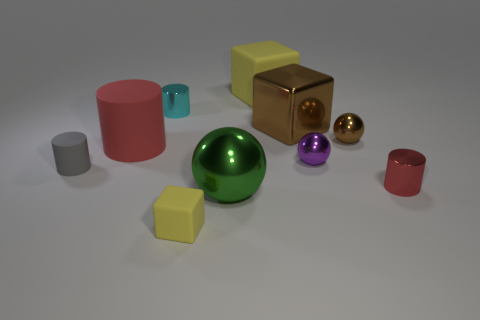What is the material of the yellow object that is in front of the small metal cylinder in front of the large brown cube?
Offer a very short reply. Rubber. Is there a brown metallic object that has the same shape as the gray thing?
Your answer should be very brief. No. What is the shape of the gray thing?
Give a very brief answer. Cylinder. There is a yellow object behind the metal cylinder in front of the brown shiny thing on the right side of the large brown thing; what is its material?
Make the answer very short. Rubber. Are there more yellow matte things to the left of the large red matte object than big green things?
Ensure brevity in your answer.  No. There is a cube that is the same size as the gray cylinder; what is its material?
Ensure brevity in your answer.  Rubber. Is there a matte cube of the same size as the cyan shiny object?
Offer a terse response. Yes. There is a shiny cylinder to the left of the brown ball; how big is it?
Offer a terse response. Small. The red metal cylinder is what size?
Offer a very short reply. Small. How many cubes are large brown rubber things or large rubber objects?
Your answer should be very brief. 1. 